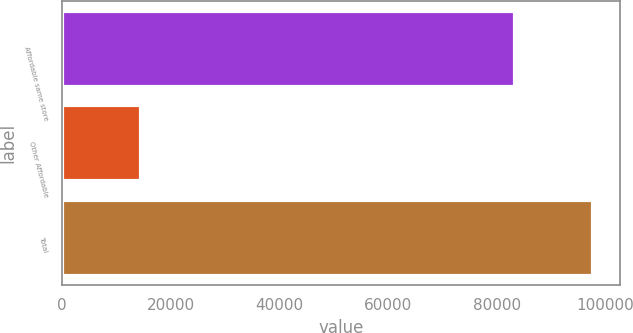<chart> <loc_0><loc_0><loc_500><loc_500><bar_chart><fcel>Affordable same store<fcel>Other Affordable<fcel>Total<nl><fcel>83282<fcel>14511<fcel>97793<nl></chart> 